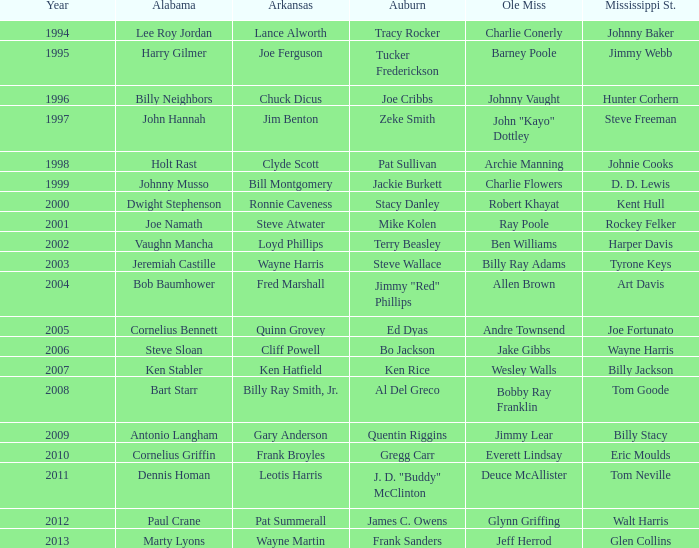Can you identify the ole miss player related to chuck dicus? Johnny Vaught. 